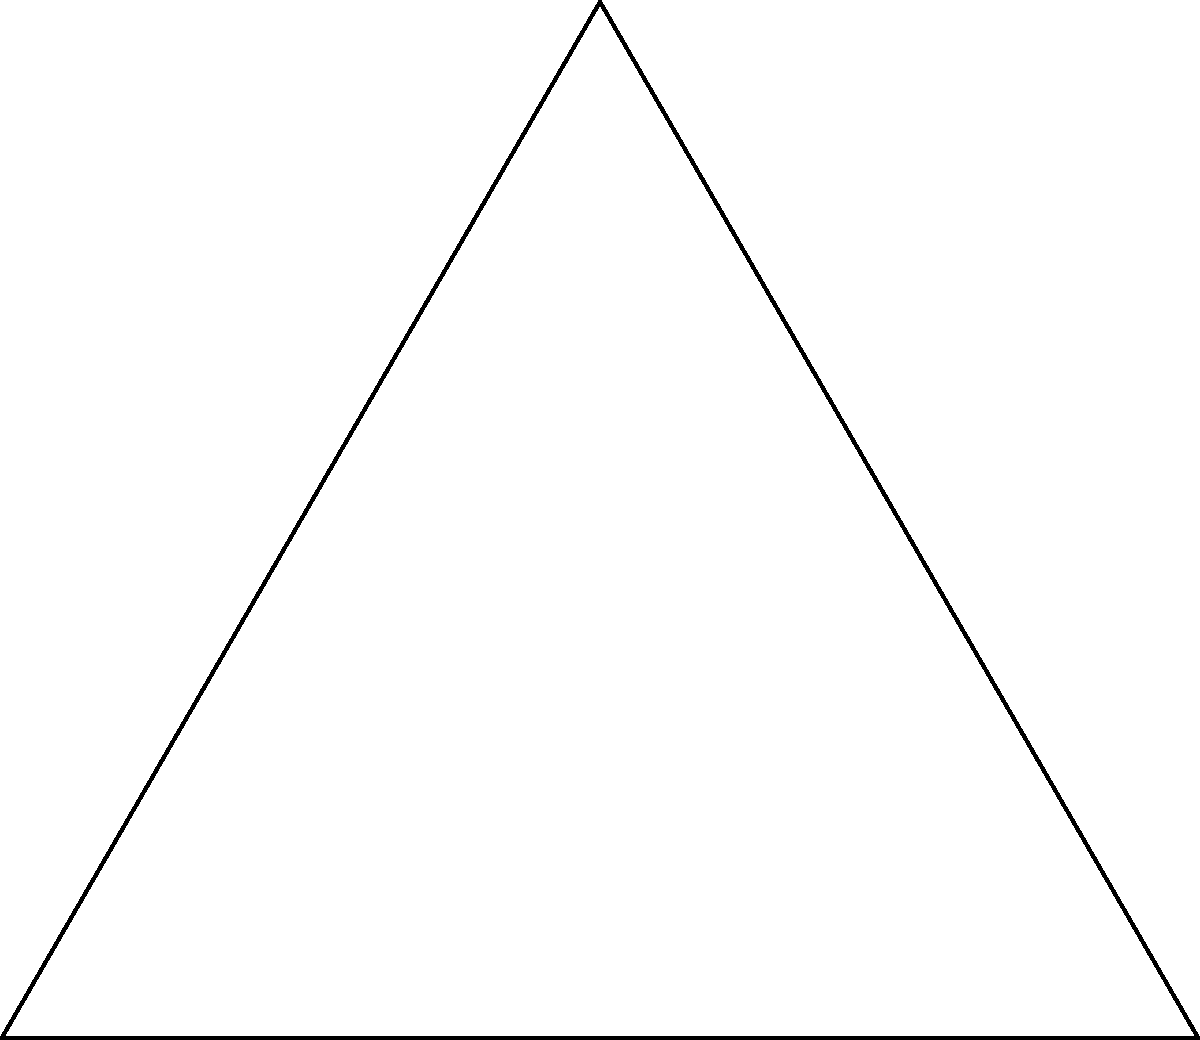The Kappa Kappa Gamma sorority pin features an equilateral triangle with three circles at its vertices. If the pin is rotated clockwise by 60°, how many degrees must it be rotated counterclockwise to return to its original position? Let's approach this step-by-step:

1) First, recall that a full rotation is 360°.

2) The pin was initially rotated 60° clockwise. This means it has moved 60° in the clockwise direction from its original position.

3) To return to its original position, we need to "undo" this rotation. In other words, we need to rotate it counterclockwise.

4) The amount of counterclockwise rotation needed is equal to the initial clockwise rotation.

5) Therefore, we need to rotate the pin 60° counterclockwise to return it to its original position.

6) Mathematically, we can express this as:

   $$\text{Counterclockwise rotation} = \text{Initial clockwise rotation} = 60°$$

This solution takes advantage of the symmetry of the equilateral triangle in the sorority pin, which allows for rotational symmetry every 120°. However, the question only rotates it by 60°, so a full 60° rotation back is needed.
Answer: 60° 